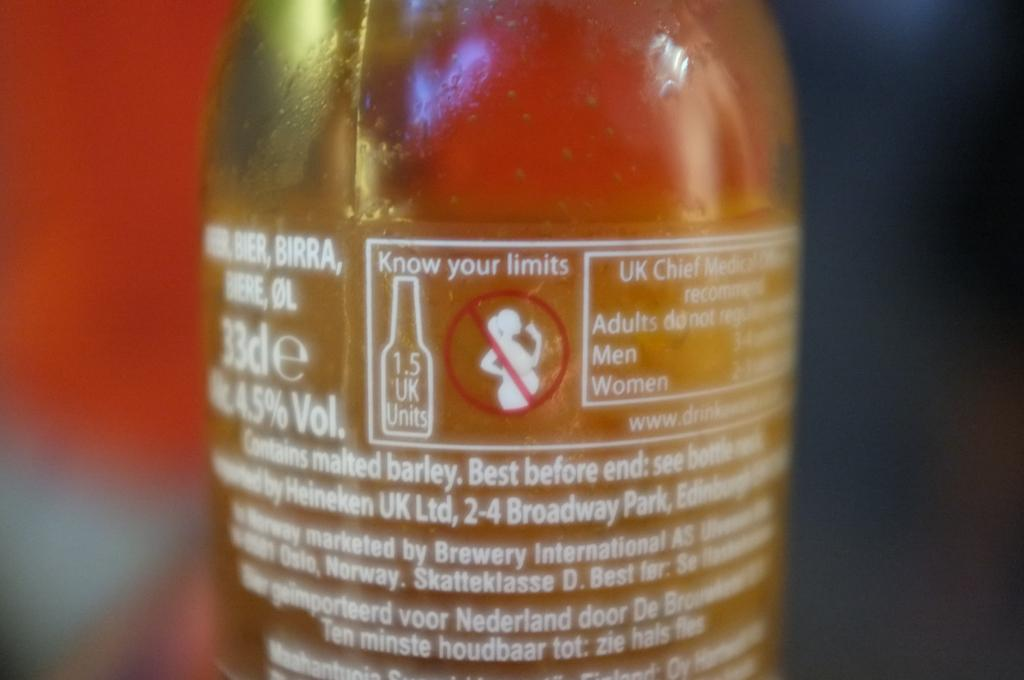What object is located in the center of the image? There is a bottle in the center of the image. What can be found on the bottle? There is text written on the bottle. What type of chicken is visible in the image? There is no chicken present in the image; it only features a bottle with text on it. 